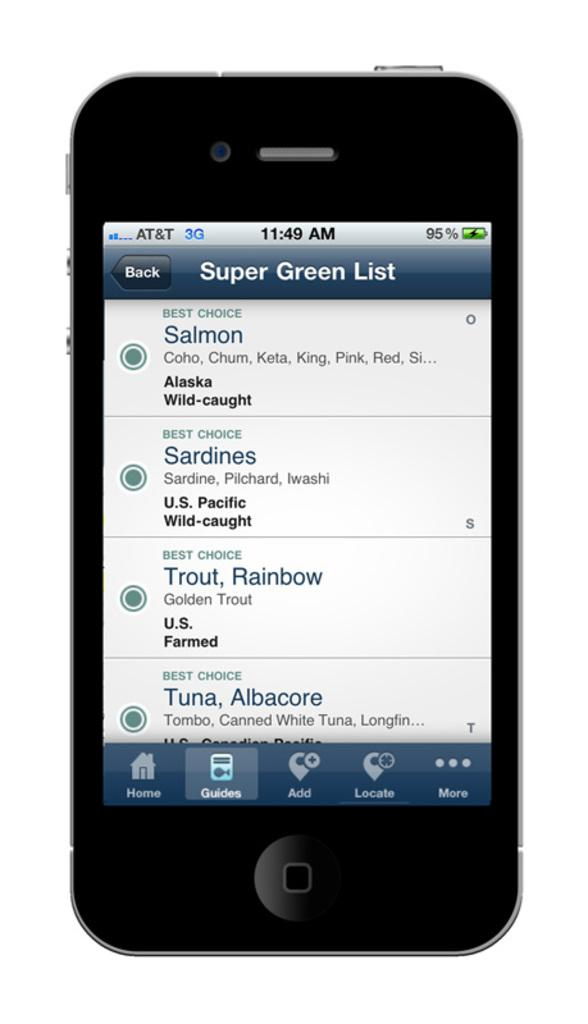<image>
Summarize the visual content of the image. A phone is open to an app, containing the Super Green List. 